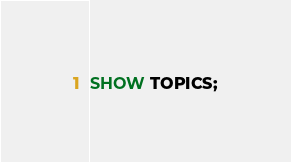Convert code to text. <code><loc_0><loc_0><loc_500><loc_500><_SQL_>
SHOW TOPICS;
</code> 